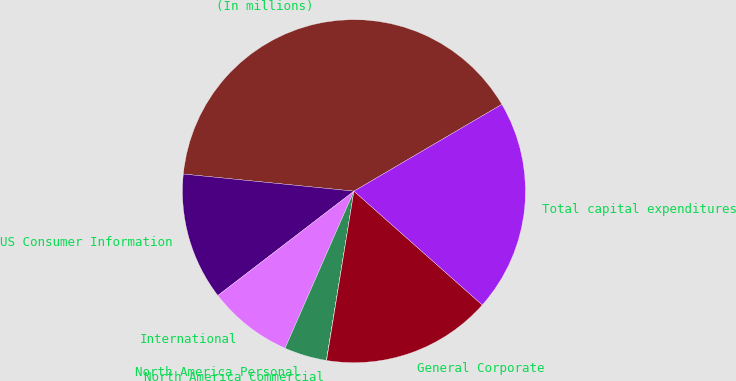Convert chart to OTSL. <chart><loc_0><loc_0><loc_500><loc_500><pie_chart><fcel>(In millions)<fcel>US Consumer Information<fcel>International<fcel>North America Personal<fcel>North America Commercial<fcel>General Corporate<fcel>Total capital expenditures<nl><fcel>39.96%<fcel>12.0%<fcel>8.01%<fcel>4.01%<fcel>0.02%<fcel>16.0%<fcel>19.99%<nl></chart> 